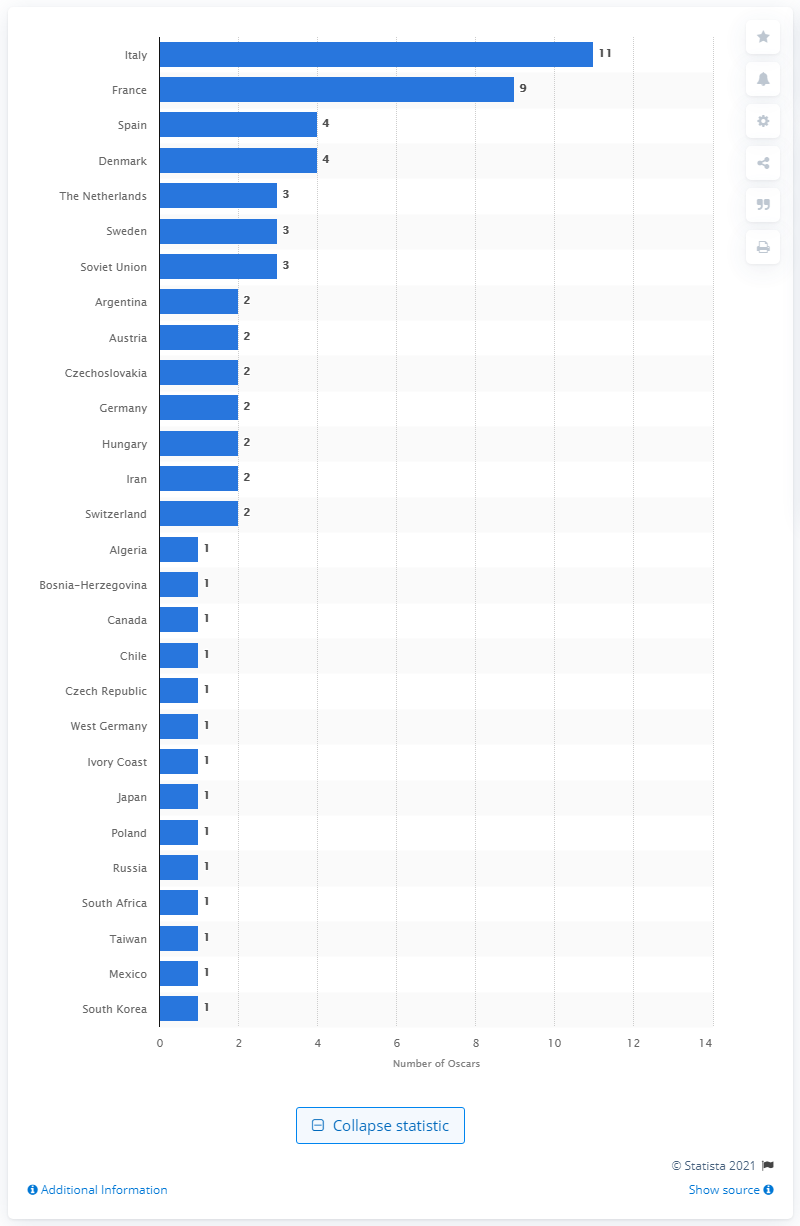Give some essential details in this illustration. Since 1948, a total of 11 Italian films have won the Oscar in the International Feature Film category. 